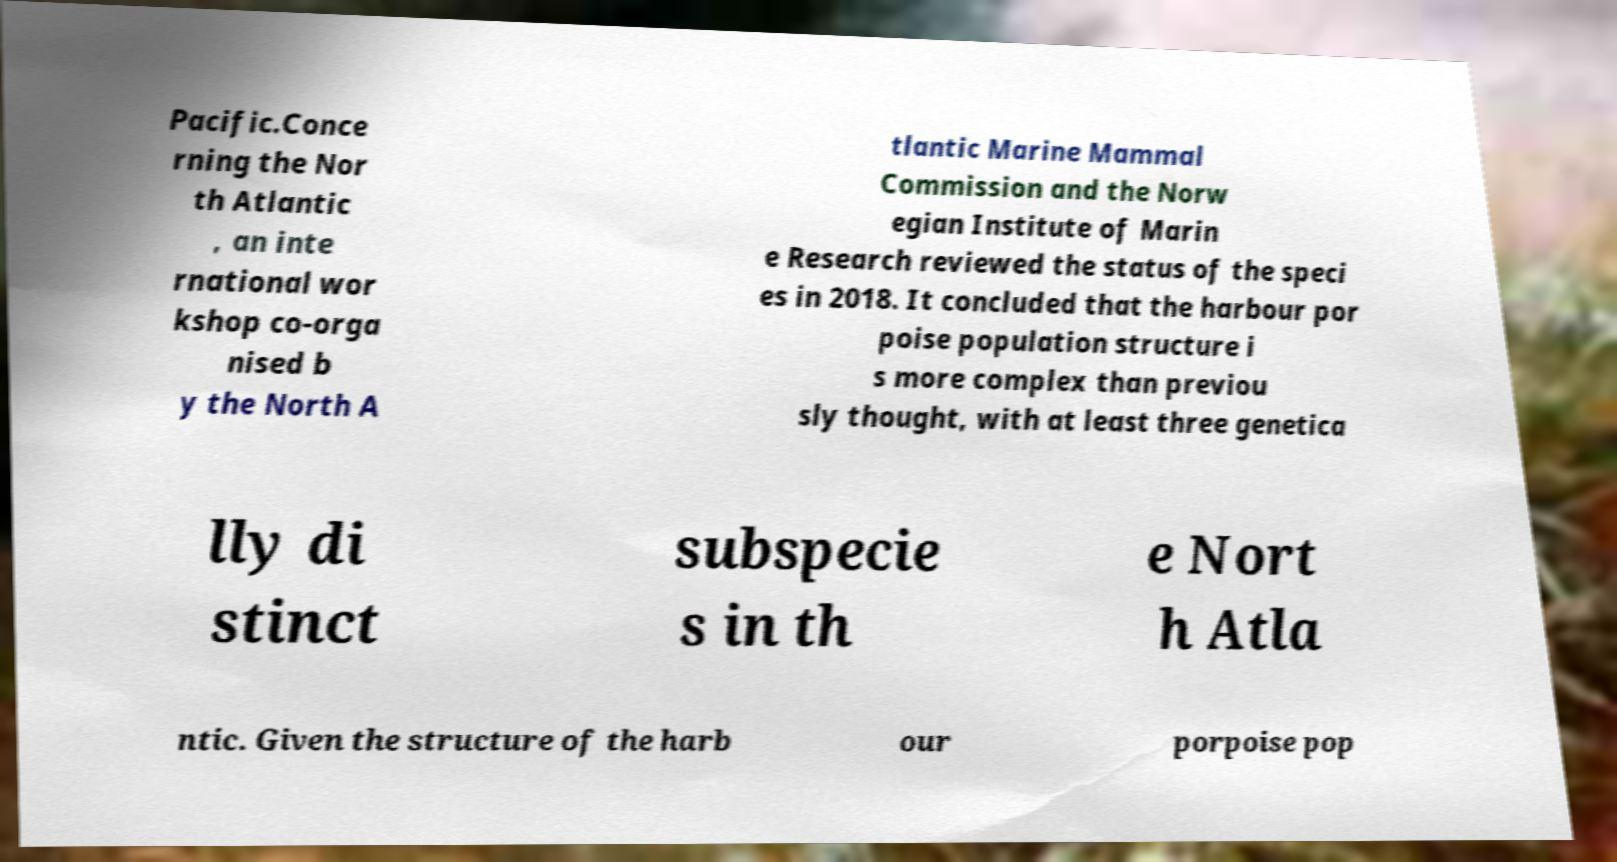Can you accurately transcribe the text from the provided image for me? Pacific.Conce rning the Nor th Atlantic , an inte rnational wor kshop co-orga nised b y the North A tlantic Marine Mammal Commission and the Norw egian Institute of Marin e Research reviewed the status of the speci es in 2018. It concluded that the harbour por poise population structure i s more complex than previou sly thought, with at least three genetica lly di stinct subspecie s in th e Nort h Atla ntic. Given the structure of the harb our porpoise pop 